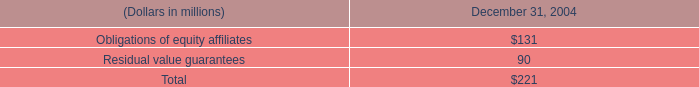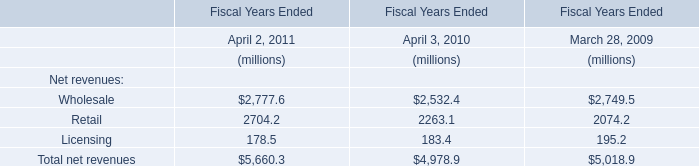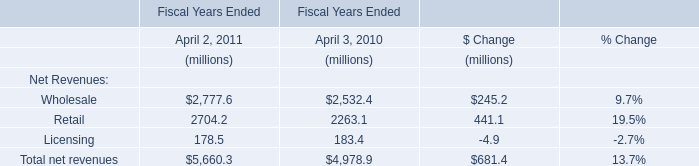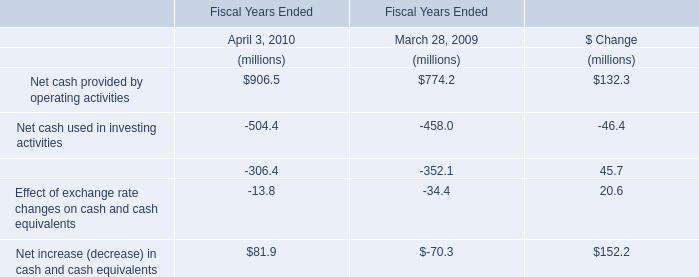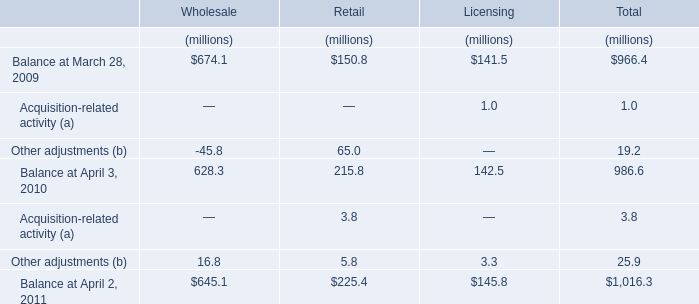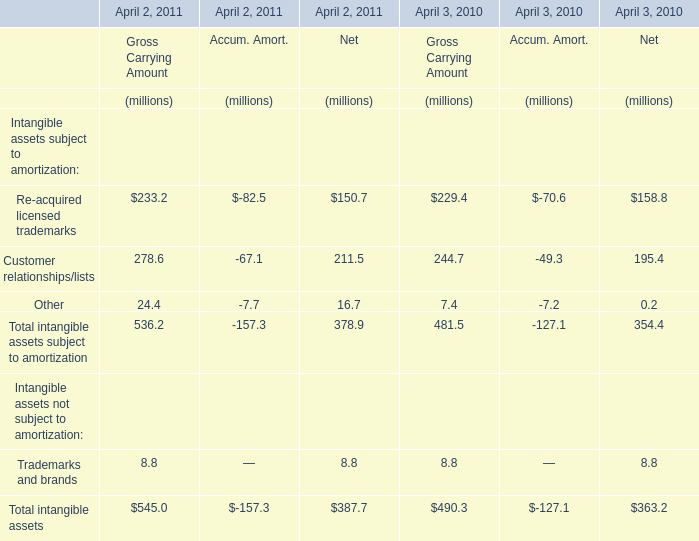Which element for Gross Carrying Amount makes up more than 40% of the total in 2010? 
Answer: Re-acquired licensed trademarks, Customer relationships/lists. 